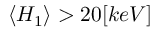Convert formula to latex. <formula><loc_0><loc_0><loc_500><loc_500>\langle H _ { 1 } \rangle > 2 0 [ k e V ]</formula> 